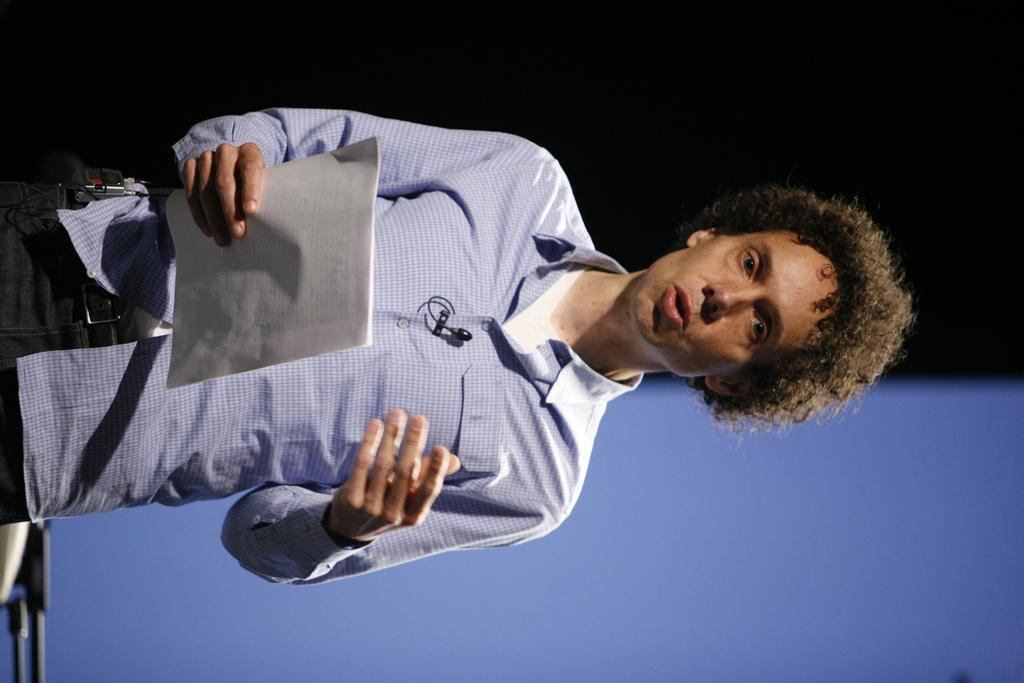Who is present in the image? There is a man in the image. What is the man holding in his hand? The man is holding papers in his hand. What type of flag is being crushed by the man in the image? There is no flag present in the image, and the man is not crushing anything. 